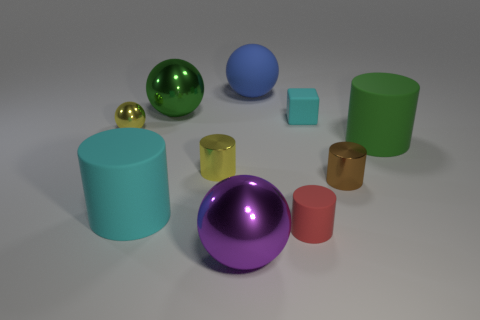There is a rubber thing that is both behind the tiny yellow metal ball and right of the large rubber ball; what is its shape?
Your answer should be very brief. Cube. Is there a cylinder right of the big rubber object that is in front of the small brown cylinder?
Your answer should be compact. Yes. Do the thing on the left side of the big cyan cylinder and the green thing behind the tiny yellow sphere have the same shape?
Make the answer very short. Yes. Are the cyan cylinder and the big green ball made of the same material?
Provide a succinct answer. No. How big is the metal cylinder behind the small shiny cylinder to the right of the tiny rubber cube behind the small brown shiny object?
Make the answer very short. Small. How many other things are there of the same color as the matte cube?
Ensure brevity in your answer.  1. There is a purple shiny object that is the same size as the blue matte thing; what shape is it?
Provide a short and direct response. Sphere. How many big objects are either purple things or cyan objects?
Ensure brevity in your answer.  2. Are there any cyan things that are in front of the large thing in front of the tiny red matte object right of the large cyan rubber thing?
Provide a succinct answer. No. Is there a metal ball of the same size as the red matte cylinder?
Give a very brief answer. Yes. 